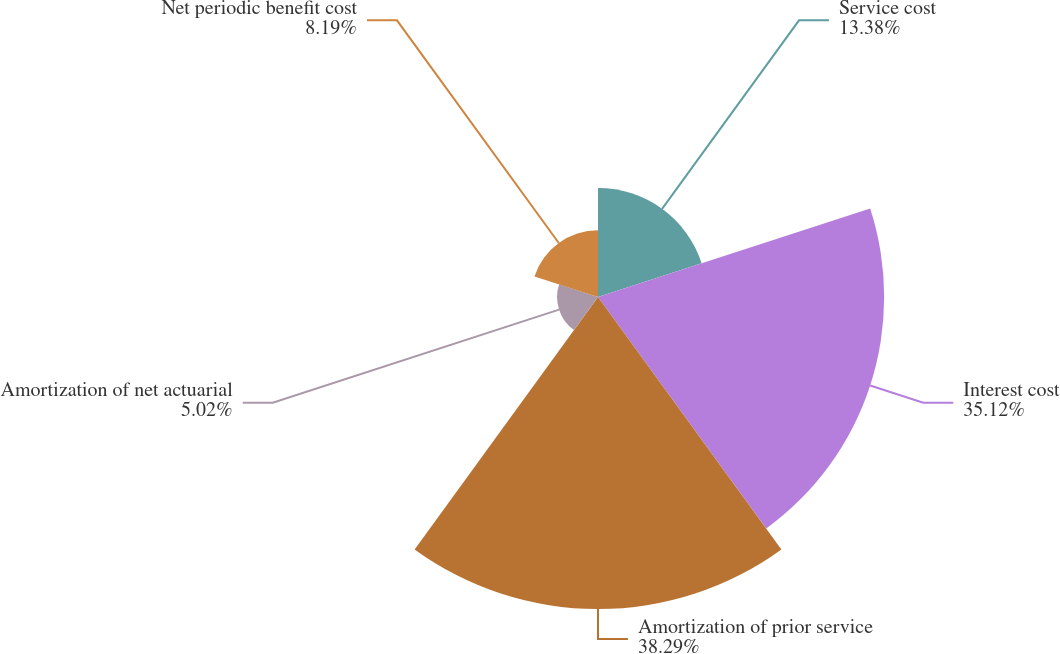Convert chart to OTSL. <chart><loc_0><loc_0><loc_500><loc_500><pie_chart><fcel>Service cost<fcel>Interest cost<fcel>Amortization of prior service<fcel>Amortization of net actuarial<fcel>Net periodic benefit cost<nl><fcel>13.38%<fcel>35.12%<fcel>38.29%<fcel>5.02%<fcel>8.19%<nl></chart> 